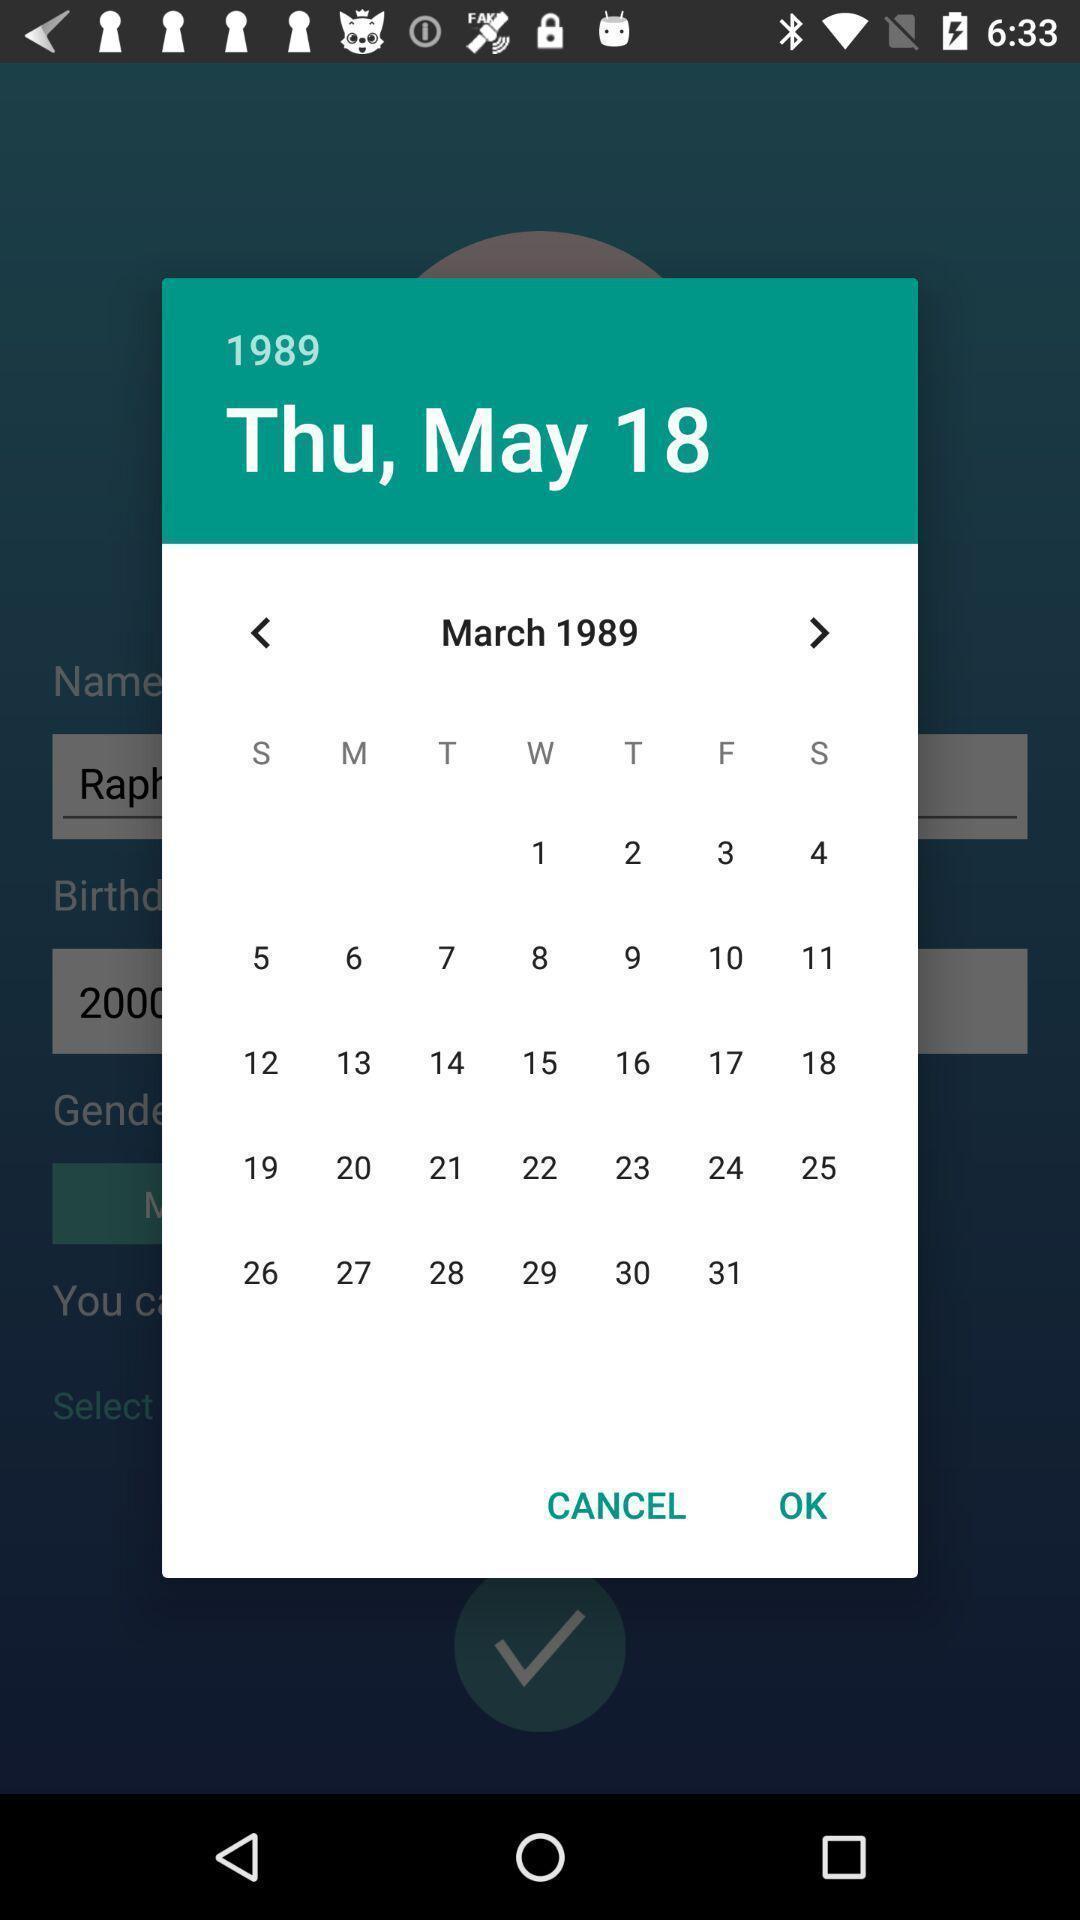Please provide a description for this image. Pop-up of calendar to select date of birth. 